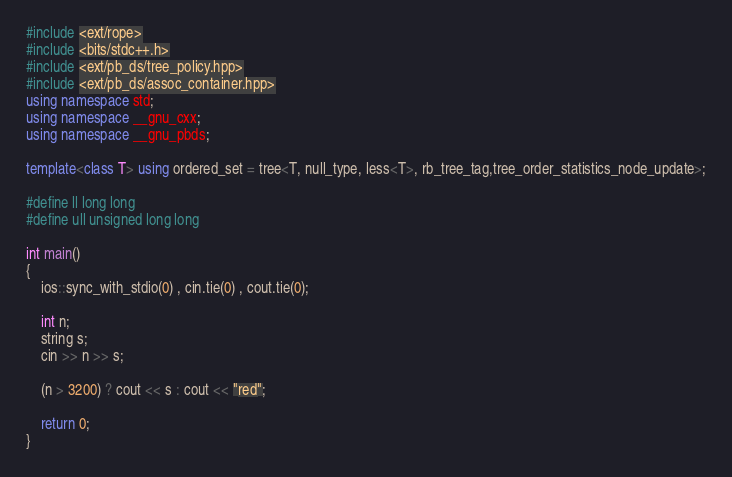<code> <loc_0><loc_0><loc_500><loc_500><_C++_>#include <ext/rope>
#include <bits/stdc++.h>
#include <ext/pb_ds/tree_policy.hpp>
#include <ext/pb_ds/assoc_container.hpp>
using namespace std;
using namespace __gnu_cxx;
using namespace __gnu_pbds;

template<class T> using ordered_set = tree<T, null_type, less<T>, rb_tree_tag,tree_order_statistics_node_update>;

#define ll long long
#define ull unsigned long long

int main()
{
    ios::sync_with_stdio(0) , cin.tie(0) , cout.tie(0);

    int n;
    string s;
    cin >> n >> s;

    (n > 3200) ? cout << s : cout << "red";

    return 0;
}
</code> 